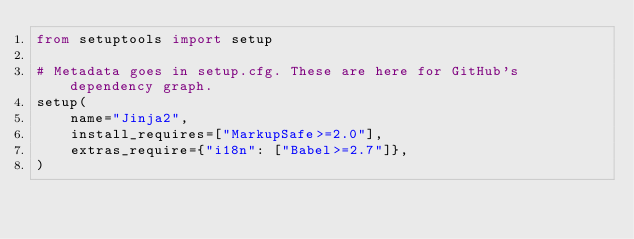<code> <loc_0><loc_0><loc_500><loc_500><_Python_>from setuptools import setup

# Metadata goes in setup.cfg. These are here for GitHub's dependency graph.
setup(
    name="Jinja2",
    install_requires=["MarkupSafe>=2.0"],
    extras_require={"i18n": ["Babel>=2.7"]},
)
</code> 